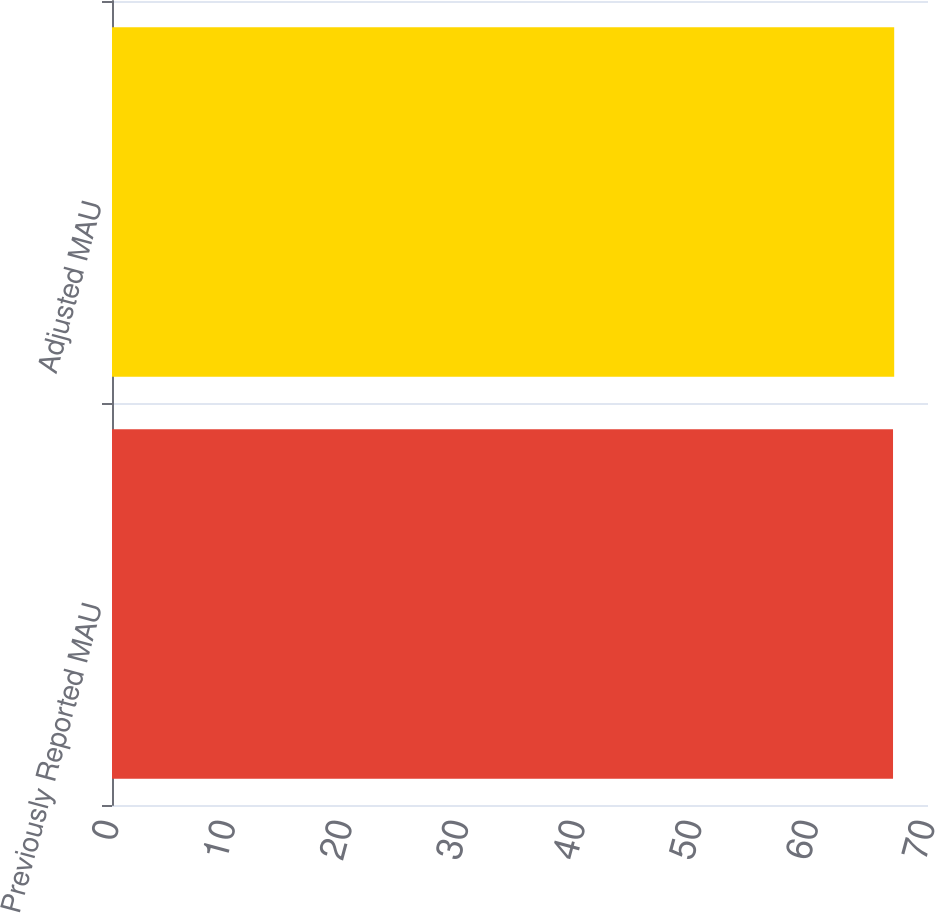Convert chart. <chart><loc_0><loc_0><loc_500><loc_500><bar_chart><fcel>Previously Reported MAU<fcel>Adjusted MAU<nl><fcel>67<fcel>67.1<nl></chart> 